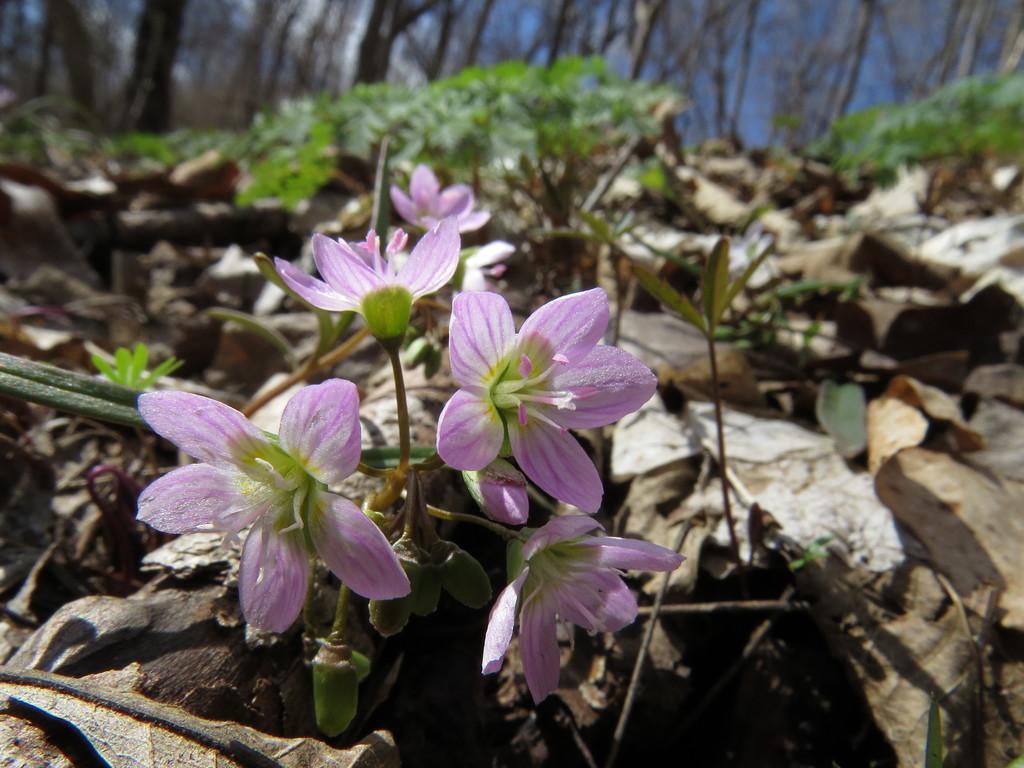How would you summarize this image in a sentence or two? In the foreground of the picture there are flowers, dry leaves and plants. The background is blurred. In the background there are trees. Sky is sunny. 